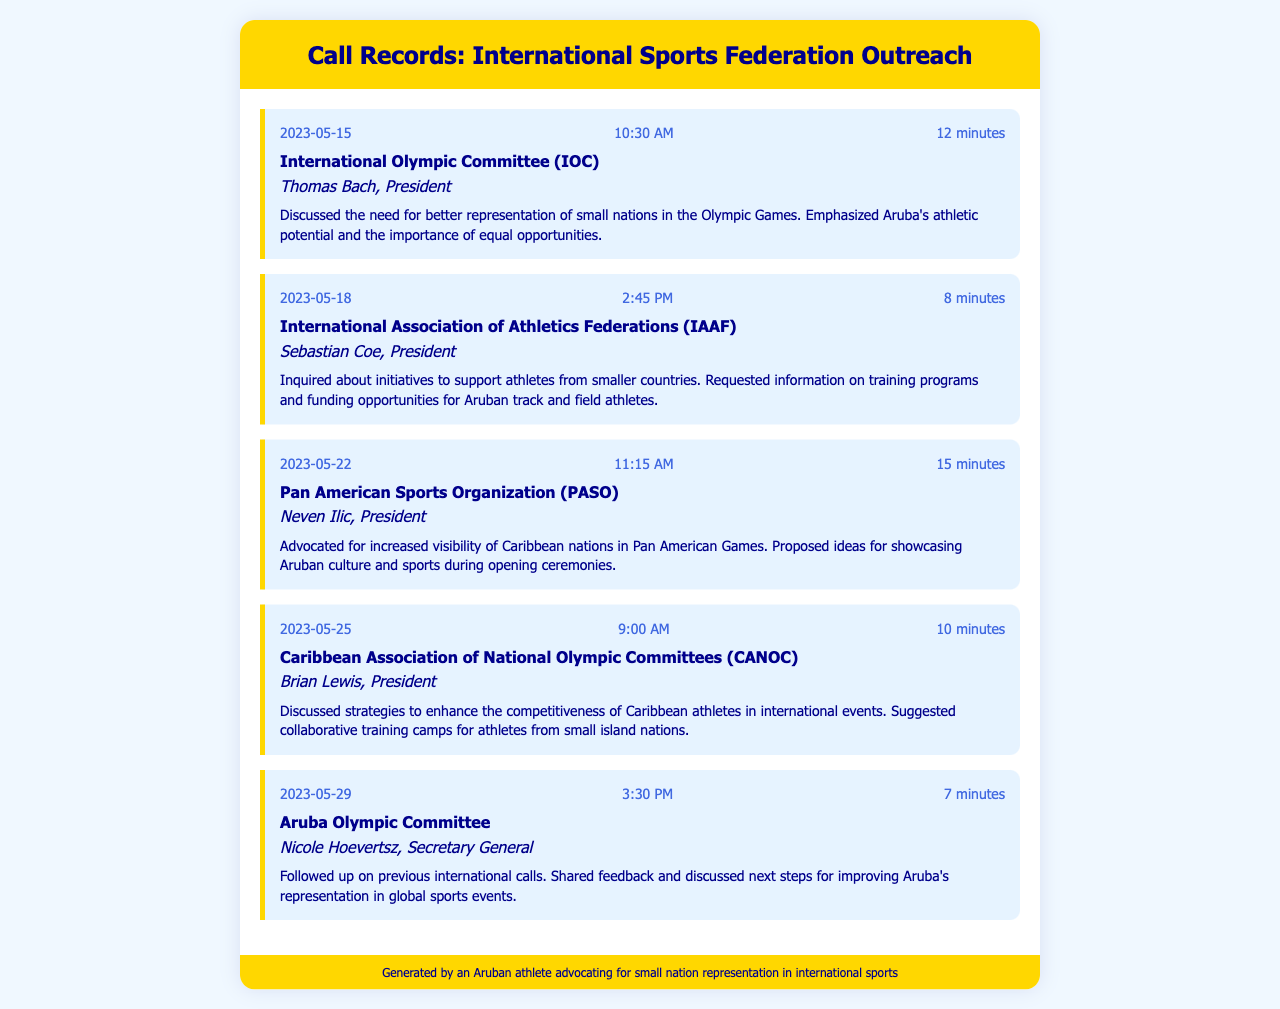what is the date of the first call? The date of the first call recorded is listed at the top of the call records section.
Answer: 2023-05-15 who is the contact for the IAAF? The call details list the contact's name and position for each organization, specifically for the IAAF.
Answer: Sebastian Coe how long was the call with the PAN American Sports Organization? The duration of each call is mentioned in the call header of the record for the PASO.
Answer: 15 minutes what initiative was inquired about during the call with the IAAF? The notes for the call outline a specific inquiry regarding initiatives related to small nation support.
Answer: Training programs and funding opportunities what was proposed for the opening ceremonies of the Pan American Games? The call notes for the PASO discuss proposals focused on cultural representation during the event.
Answer: Showcasing Aruban culture and sports who followed up on international calls with the Aruba Olympic Committee? Each call lists details including the contact's name for follow-ups; in this case, it's noted for the Aruba Olympic Committee.
Answer: Nicole Hoevertsz what strategy was discussed to enhance competitiveness in international events? The call with the Caribbean Association of National Olympic Committees mentions specific strategies to aid Caribbean athletes.
Answer: Collaborative training camps how many minutes did the call with the IOC last? The duration of the call with the IOC is specified in the corresponding call header.
Answer: 12 minutes 